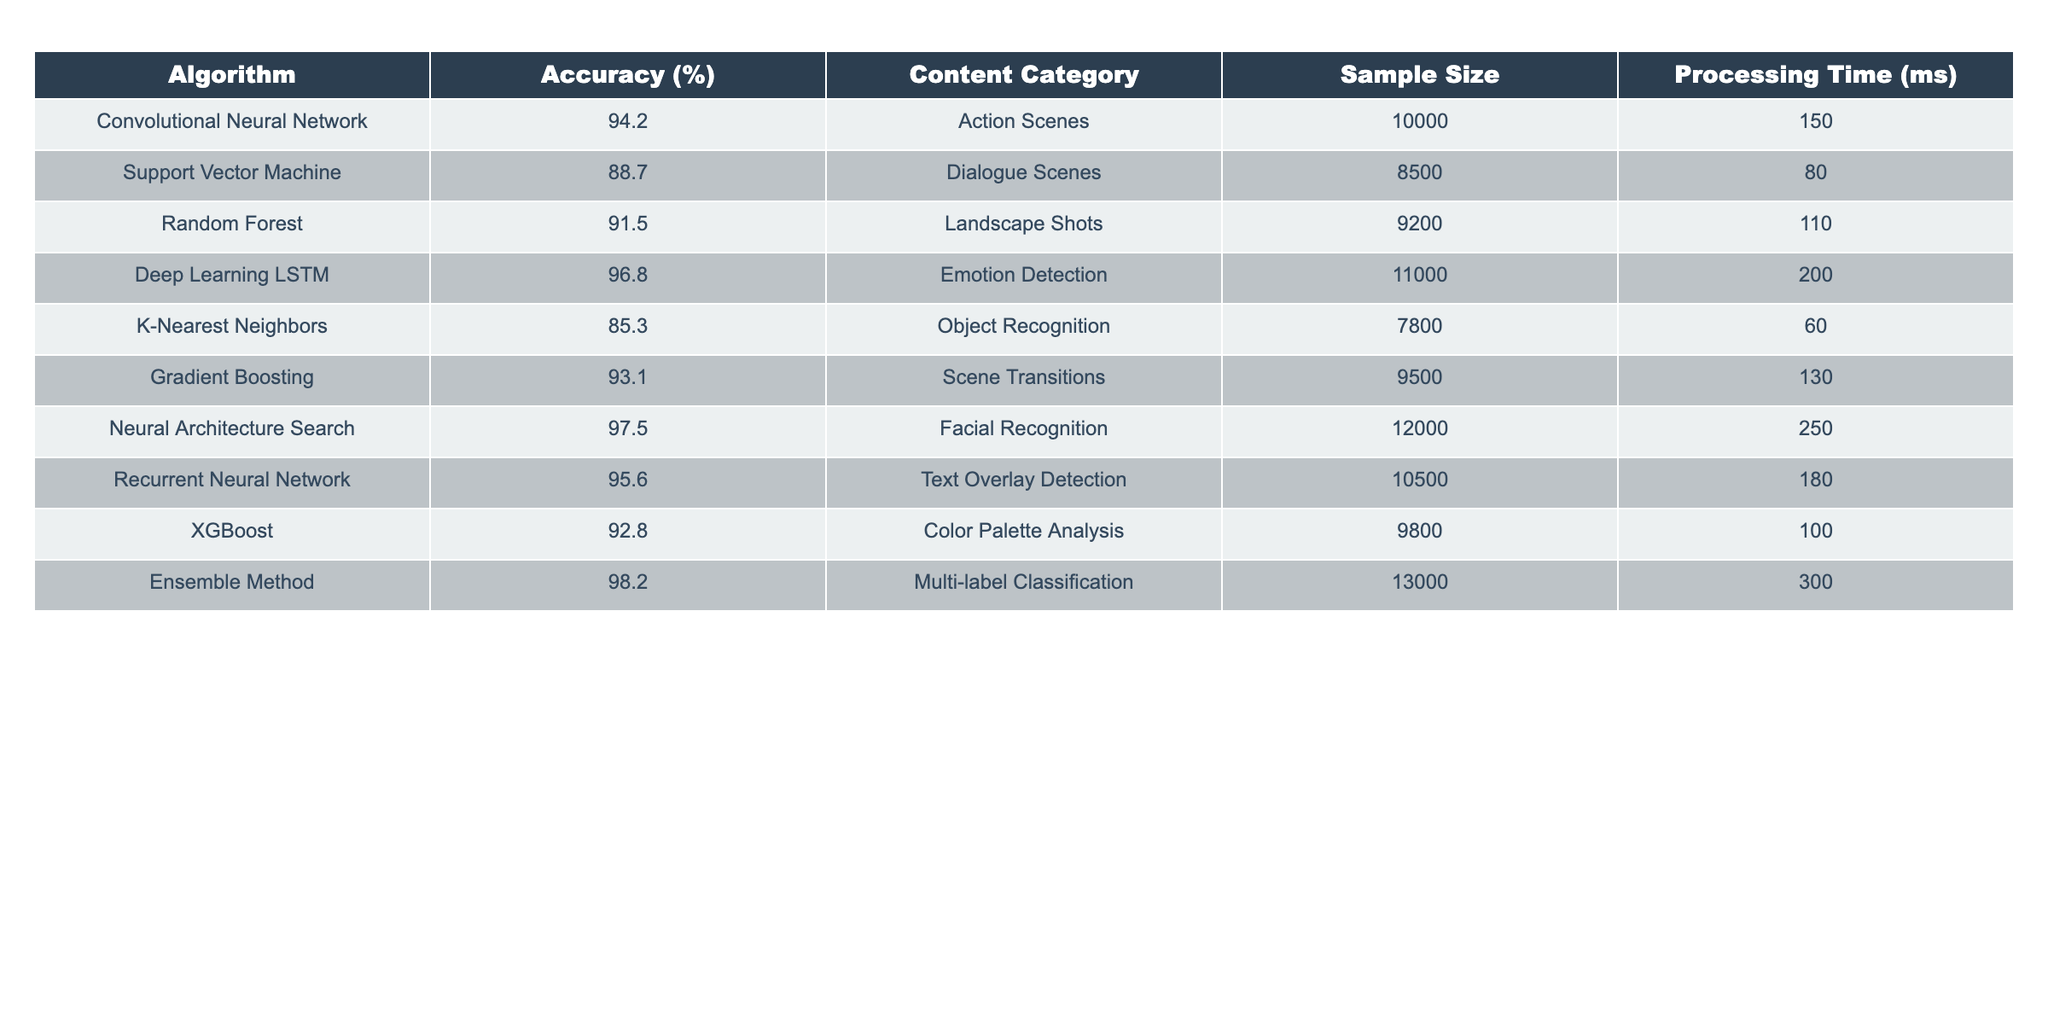What is the accuracy of the Deep Learning LSTM algorithm? The Deep Learning LSTM algorithm has an accuracy of 96.8%, as stated in the accuracy column of the table.
Answer: 96.8% Which algorithm detects Emotion Detection with the highest accuracy? The algorithm that detects Emotion Detection with the highest accuracy is Deep Learning LSTM, with an accuracy of 96.8%.
Answer: Deep Learning LSTM What is the content category for the K-Nearest Neighbors algorithm? The content category for the K-Nearest Neighbors algorithm is Object Recognition, which is listed in the respective column of the table.
Answer: Object Recognition How many algorithms have an accuracy higher than 90%? By looking at the accuracy values, six algorithms have an accuracy higher than 90%: Convolutional Neural Network, Random Forest, Deep Learning LSTM, Gradient Boosting, Neural Architecture Search, and Ensemble Method.
Answer: 6 What is the processing time difference between the Ensemble Method and the K-Nearest Neighbors algorithm? The Ensemble Method has a processing time of 300 ms and the K-Nearest Neighbors algorithm has a processing time of 60 ms. The difference is 300 - 60 = 240 ms.
Answer: 240 ms Is the accuracy of the Support Vector Machine algorithm greater than 90%? The accuracy of the Support Vector Machine algorithm is 88.7%, which is less than 90%. Therefore, the statement is false.
Answer: No Which algorithm has the longest processing time, and what is the duration? The Ensemble Method has the longest processing time of 300 ms, identified by comparing all processing times in the table.
Answer: 300 ms Calculate the average accuracy of the algorithms that focus on scene analysis (Action Scenes, Landscape Shots, and Scene Transitions). The accuracies for Action Scenes (94.2%), Landscape Shots (91.5%), and Scene Transitions (93.1%) are summed: 94.2 + 91.5 + 93.1 = 278.8. Dividing by 3 gives an average accuracy of 92.93%.
Answer: 92.93% Which algorithm is specifically designed for Facial Recognition, and what is its accuracy? The Neural Architecture Search algorithm is specifically designed for Facial Recognition, and its accuracy is 97.5%, as indicated in the table.
Answer: Neural Architecture Search, 97.5% If we combine the sample sizes of all algorithms, what is the total sample size? The total sample size is calculated by summing all sample sizes: 10000 + 8500 + 9200 + 11000 + 7800 + 9500 + 12000 + 10500 + 9800 + 13000 = 101300.
Answer: 101300 